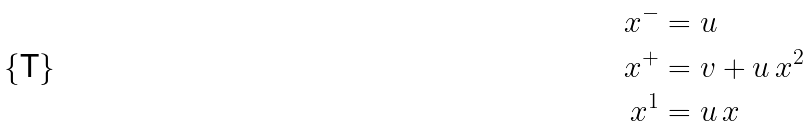Convert formula to latex. <formula><loc_0><loc_0><loc_500><loc_500>x ^ { - } & = u \\ x ^ { + } & = v + u \, x ^ { 2 } \\ x ^ { 1 } & = u \, x</formula> 